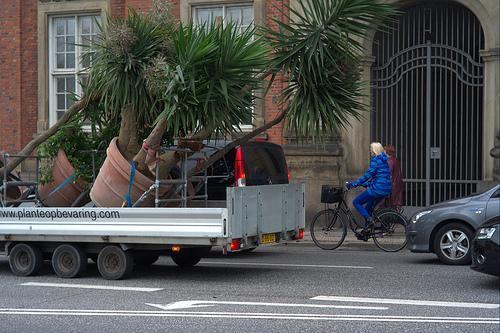How many Palm trees are in the picture?
Give a very brief answer. 6. 